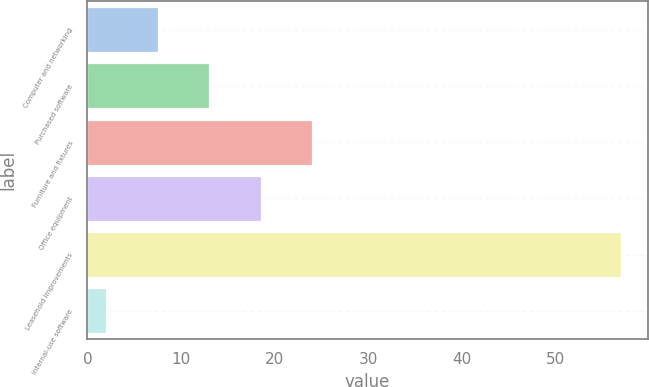<chart> <loc_0><loc_0><loc_500><loc_500><bar_chart><fcel>Computer and networking<fcel>Purchased software<fcel>Furniture and fixtures<fcel>Office equipment<fcel>Leasehold improvements<fcel>Internal-use software<nl><fcel>7.5<fcel>13<fcel>24<fcel>18.5<fcel>57<fcel>2<nl></chart> 